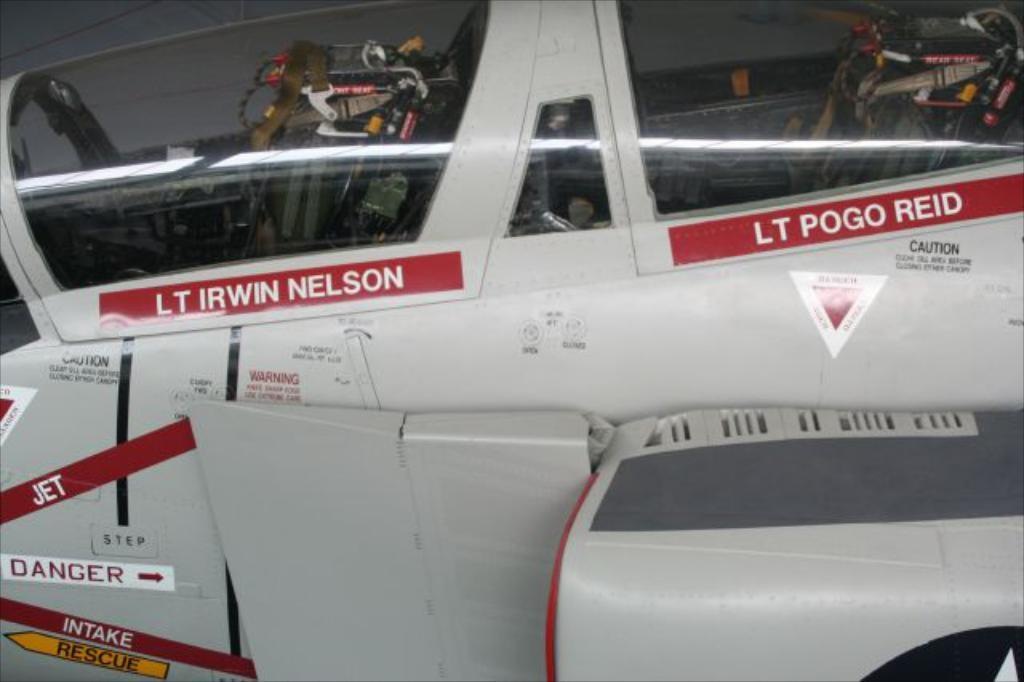Provide a one-sentence caption for the provided image. a cockpit of a jet with the name LT Irwin Nelson on the side. 